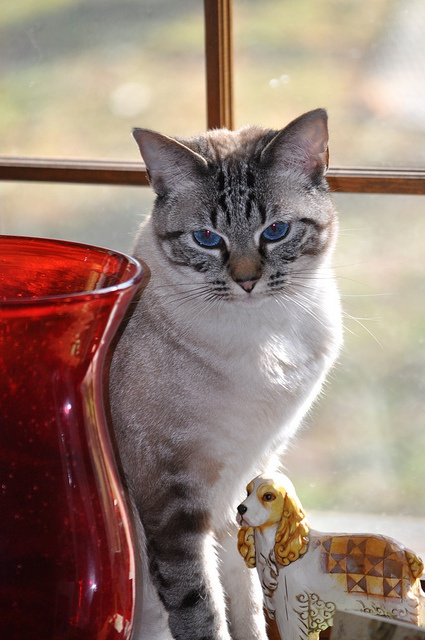Describe the objects in this image and their specific colors. I can see cat in tan, gray, darkgray, black, and lightgray tones, vase in tan, maroon, black, brown, and red tones, and dog in tan, darkgray, brown, gray, and maroon tones in this image. 